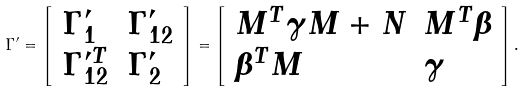Convert formula to latex. <formula><loc_0><loc_0><loc_500><loc_500>\Gamma ^ { \prime } = \left [ \begin{array} { l l } \Gamma _ { 1 } ^ { \prime } & \Gamma _ { 1 2 } ^ { \prime } \\ \Gamma _ { 1 2 } ^ { \prime T } & \Gamma _ { 2 } ^ { \prime } \end{array} \right ] = \left [ \begin{array} { l l } M ^ { T } \gamma M + N & M ^ { T } \beta \\ \beta ^ { T } M & \gamma \end{array} \right ] .</formula> 